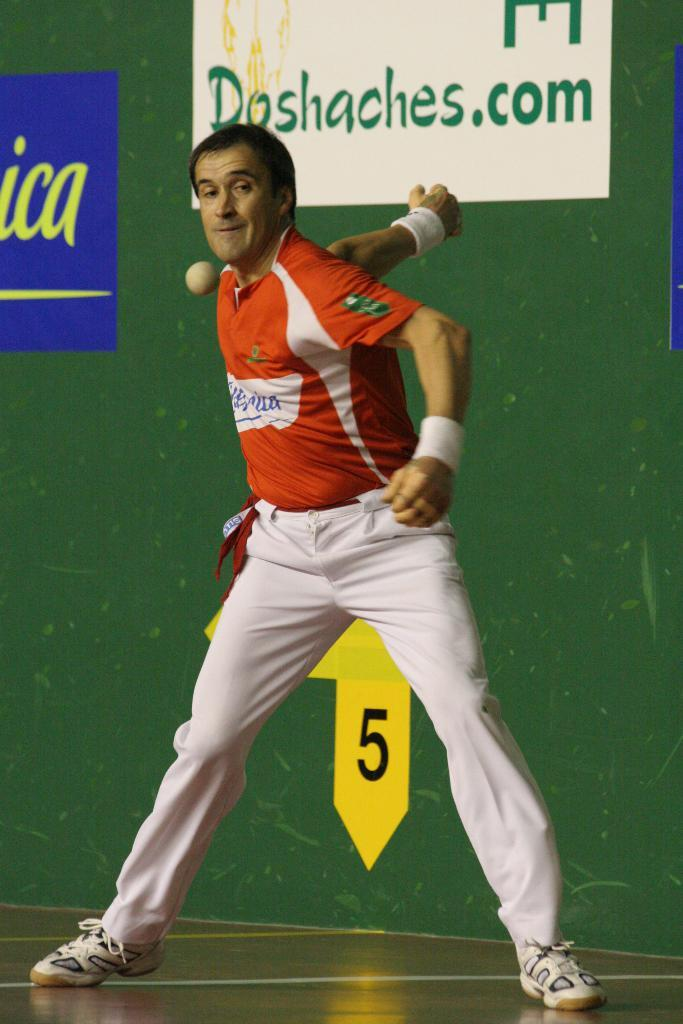<image>
Summarize the visual content of the image. the number 5 is on an area under the man's knees 